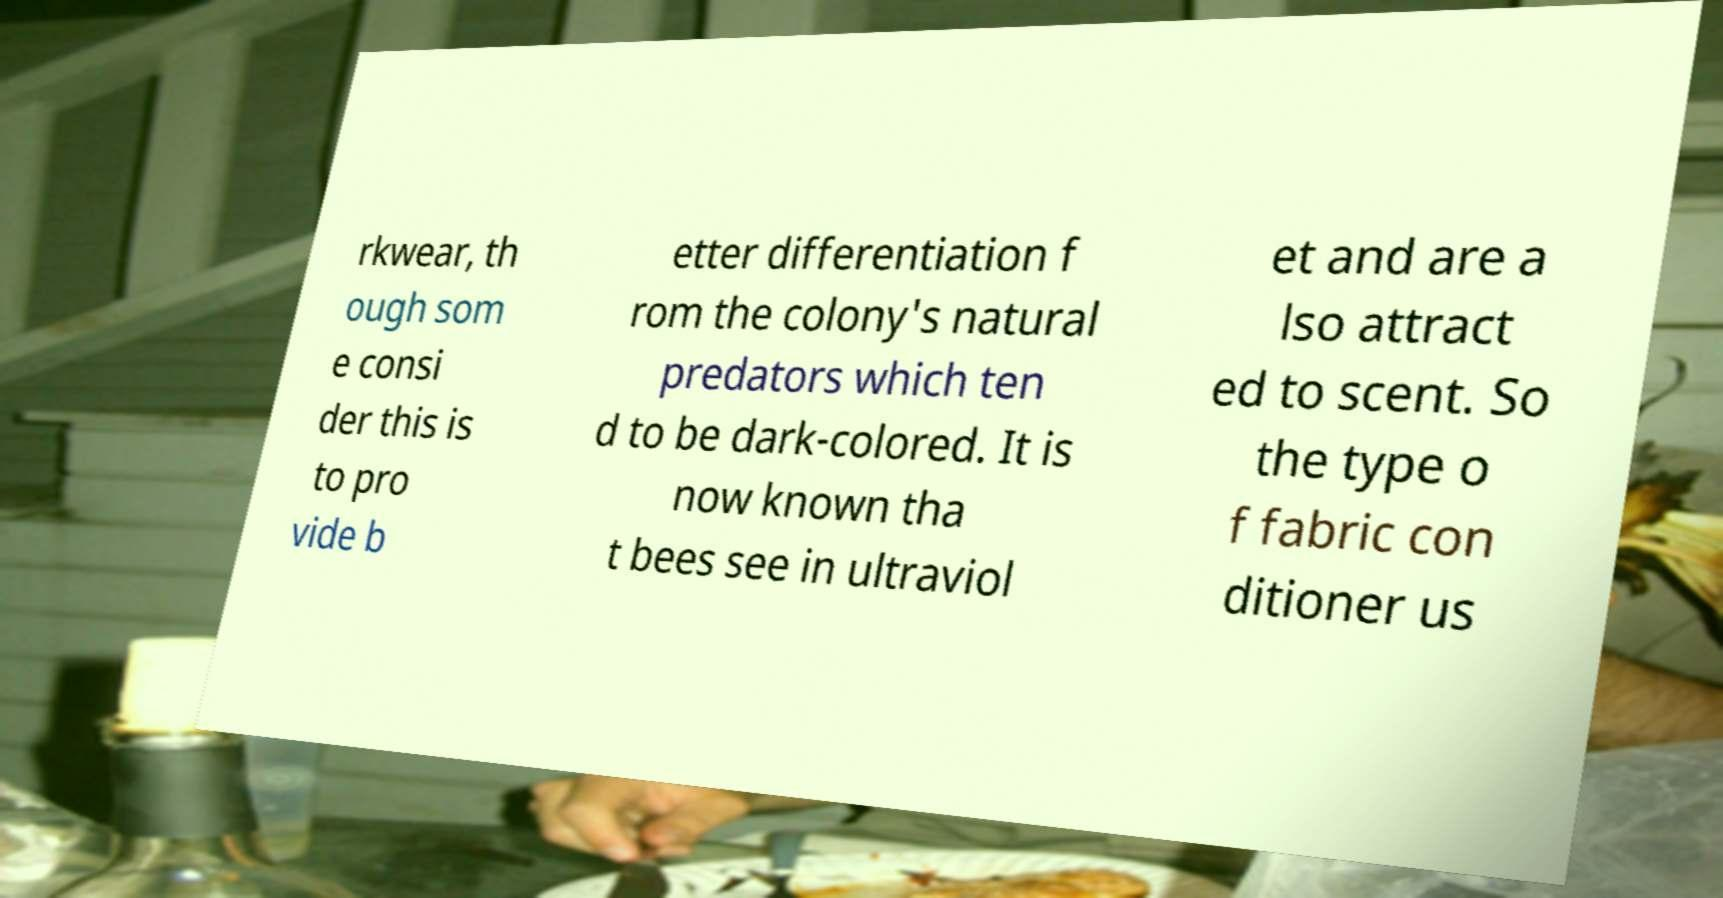Could you assist in decoding the text presented in this image and type it out clearly? rkwear, th ough som e consi der this is to pro vide b etter differentiation f rom the colony's natural predators which ten d to be dark-colored. It is now known tha t bees see in ultraviol et and are a lso attract ed to scent. So the type o f fabric con ditioner us 